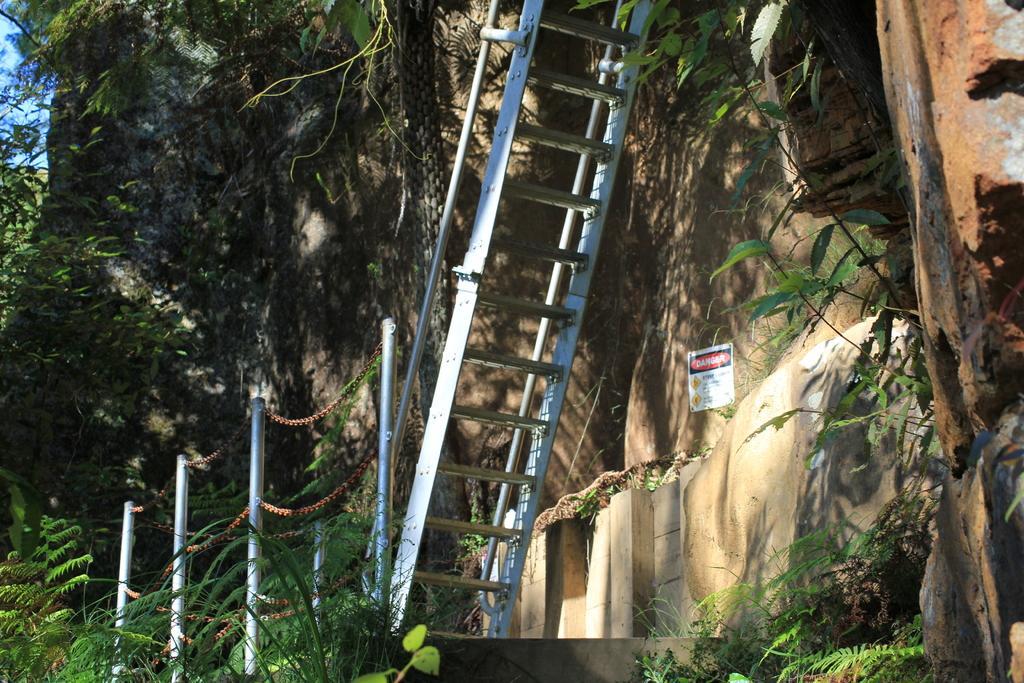Can you describe this image briefly? In this picture there is a steel ladder near to the fencing. On the right there is a poster on the wall. Here we can see the plants on the building. On the left we can see the trees. At the top left corner there is a sky. In the bottom we can see the leaves and grass. 